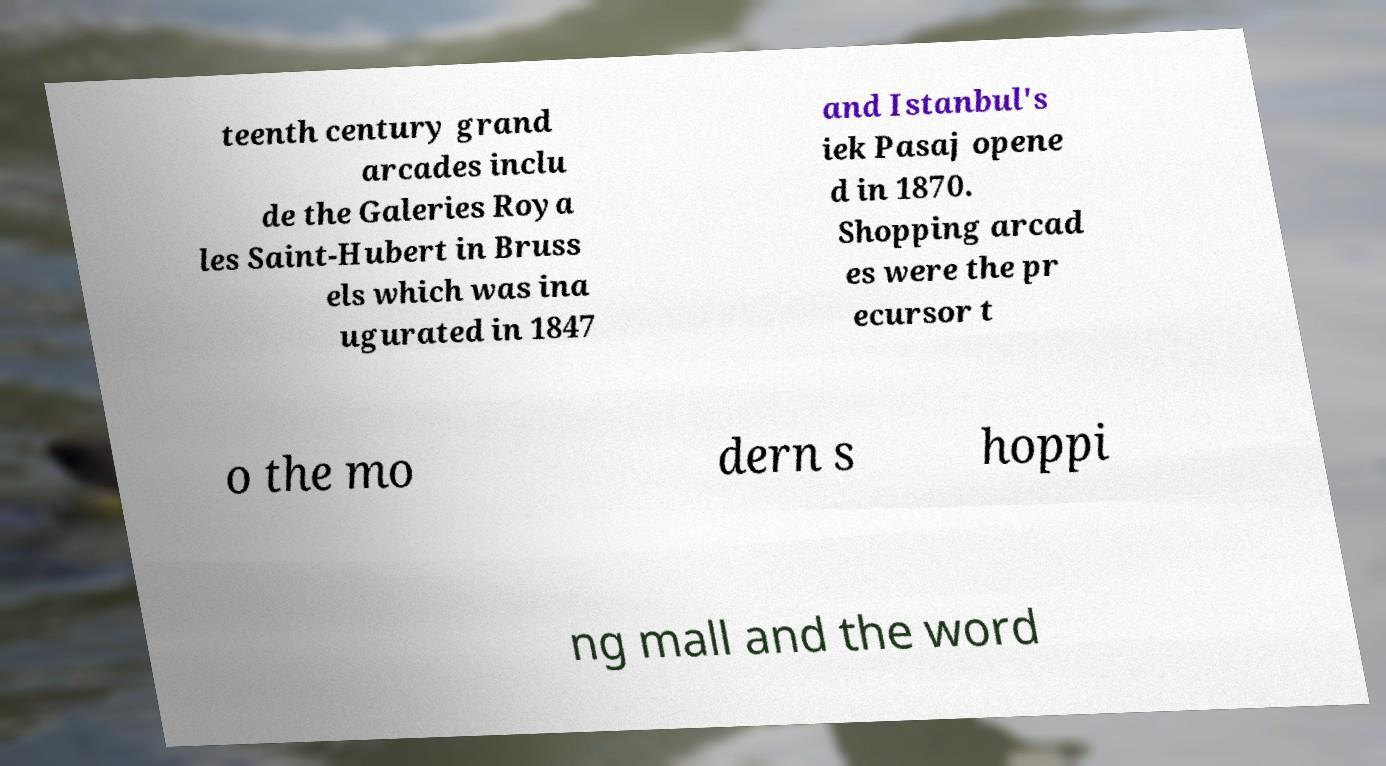Could you assist in decoding the text presented in this image and type it out clearly? teenth century grand arcades inclu de the Galeries Roya les Saint-Hubert in Bruss els which was ina ugurated in 1847 and Istanbul's iek Pasaj opene d in 1870. Shopping arcad es were the pr ecursor t o the mo dern s hoppi ng mall and the word 